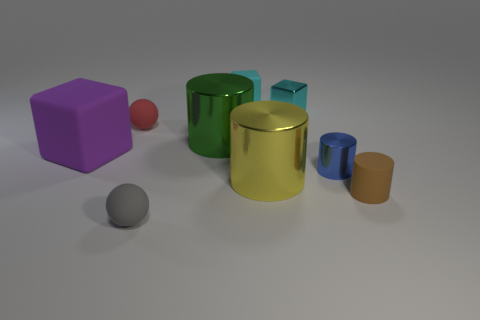There is a rubber block that is right of the purple cube; is it the same size as the tiny blue cylinder?
Your answer should be very brief. Yes. There is a sphere that is in front of the small brown object; what size is it?
Keep it short and to the point. Small. Is there any other thing that is made of the same material as the large cube?
Offer a very short reply. Yes. How many big yellow things are there?
Your response must be concise. 1. Is the color of the small rubber cube the same as the small matte cylinder?
Give a very brief answer. No. What color is the thing that is in front of the red object and behind the large purple matte block?
Your response must be concise. Green. Are there any big yellow cylinders on the right side of the small blue object?
Offer a terse response. No. There is a sphere that is behind the gray object; how many brown matte cylinders are to the right of it?
Your answer should be very brief. 1. What size is the cyan block that is the same material as the small red thing?
Make the answer very short. Small. The brown object has what size?
Provide a short and direct response. Small. 